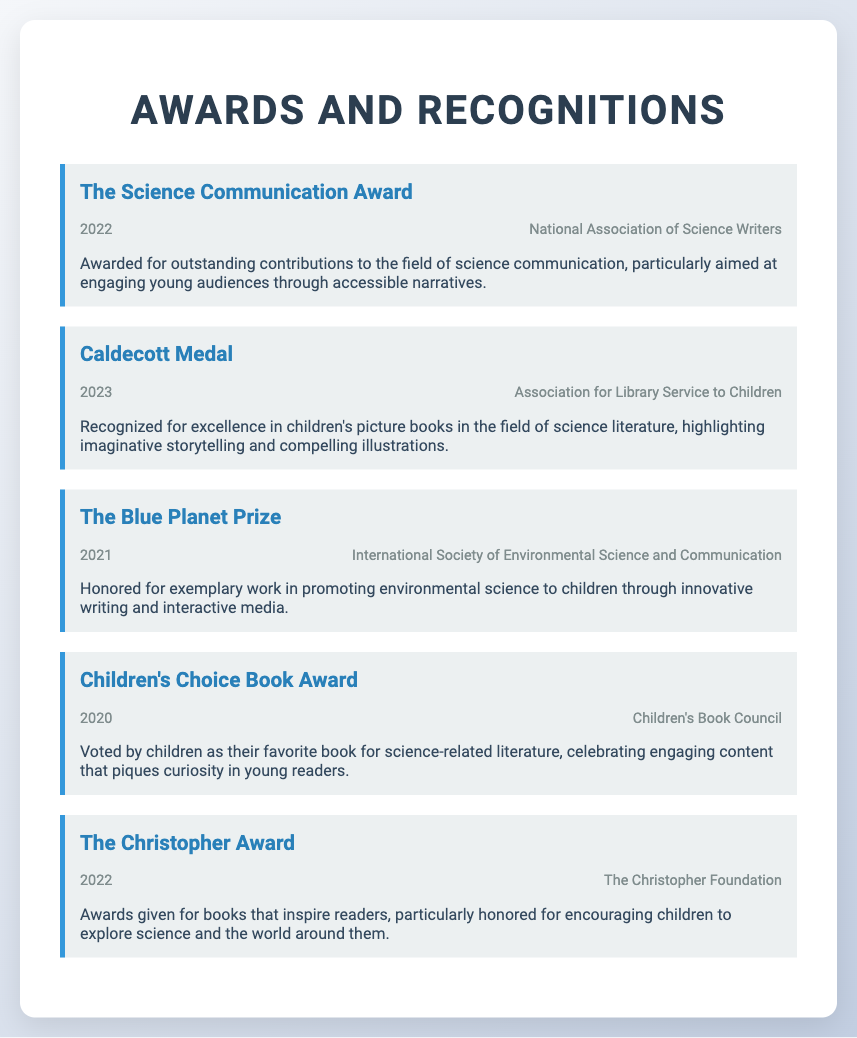What award did the National Association of Science Writers give in 2022? The award was given for outstanding contributions to the field of science communication, particularly aimed at engaging young audiences through accessible narratives.
Answer: The Science Communication Award What year was the Caldecott Medal awarded? The year that the Caldecott Medal was awarded is mentioned in the document.
Answer: 2023 Which organization awarded The Blue Planet Prize in 2021? The document specifies the awarding organization for The Blue Planet Prize.
Answer: International Society of Environmental Science and Communication What is the Children's Choice Book Award based on? The award is voted on by a specific group, emphasized in the document.
Answer: By children What is the focus of The Christopher Award? The award is given for books that inspire a particular audience, as specified in the document.
Answer: Encouraging children How many awards are listed in the document? The total number of awards mentioned provides insight into the writer's recognitions.
Answer: Five 